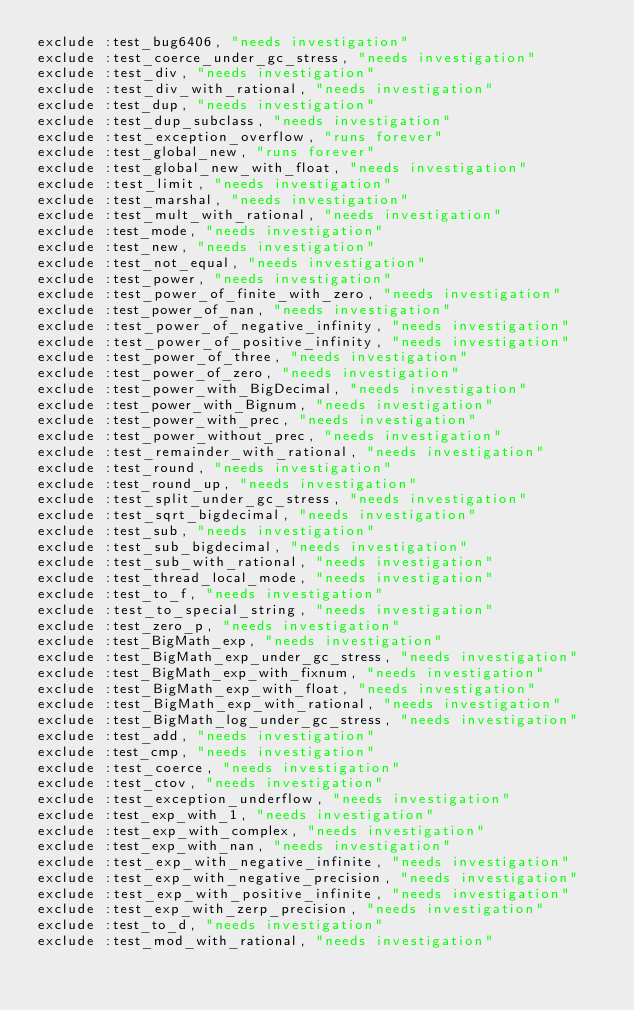Convert code to text. <code><loc_0><loc_0><loc_500><loc_500><_Ruby_>exclude :test_bug6406, "needs investigation"
exclude :test_coerce_under_gc_stress, "needs investigation"
exclude :test_div, "needs investigation"
exclude :test_div_with_rational, "needs investigation"
exclude :test_dup, "needs investigation"
exclude :test_dup_subclass, "needs investigation"
exclude :test_exception_overflow, "runs forever"
exclude :test_global_new, "runs forever"
exclude :test_global_new_with_float, "needs investigation"
exclude :test_limit, "needs investigation"
exclude :test_marshal, "needs investigation"
exclude :test_mult_with_rational, "needs investigation"
exclude :test_mode, "needs investigation"
exclude :test_new, "needs investigation"
exclude :test_not_equal, "needs investigation"
exclude :test_power, "needs investigation"
exclude :test_power_of_finite_with_zero, "needs investigation"
exclude :test_power_of_nan, "needs investigation"
exclude :test_power_of_negative_infinity, "needs investigation"
exclude :test_power_of_positive_infinity, "needs investigation"
exclude :test_power_of_three, "needs investigation"
exclude :test_power_of_zero, "needs investigation"
exclude :test_power_with_BigDecimal, "needs investigation"
exclude :test_power_with_Bignum, "needs investigation"
exclude :test_power_with_prec, "needs investigation"
exclude :test_power_without_prec, "needs investigation"
exclude :test_remainder_with_rational, "needs investigation"
exclude :test_round, "needs investigation"
exclude :test_round_up, "needs investigation"
exclude :test_split_under_gc_stress, "needs investigation"
exclude :test_sqrt_bigdecimal, "needs investigation"
exclude :test_sub, "needs investigation"
exclude :test_sub_bigdecimal, "needs investigation"
exclude :test_sub_with_rational, "needs investigation"
exclude :test_thread_local_mode, "needs investigation"
exclude :test_to_f, "needs investigation"
exclude :test_to_special_string, "needs investigation"
exclude :test_zero_p, "needs investigation"
exclude :test_BigMath_exp, "needs investigation"
exclude :test_BigMath_exp_under_gc_stress, "needs investigation"
exclude :test_BigMath_exp_with_fixnum, "needs investigation"
exclude :test_BigMath_exp_with_float, "needs investigation"
exclude :test_BigMath_exp_with_rational, "needs investigation"
exclude :test_BigMath_log_under_gc_stress, "needs investigation"
exclude :test_add, "needs investigation"
exclude :test_cmp, "needs investigation"
exclude :test_coerce, "needs investigation"
exclude :test_ctov, "needs investigation"
exclude :test_exception_underflow, "needs investigation"
exclude :test_exp_with_1, "needs investigation"
exclude :test_exp_with_complex, "needs investigation"
exclude :test_exp_with_nan, "needs investigation"
exclude :test_exp_with_negative_infinite, "needs investigation"
exclude :test_exp_with_negative_precision, "needs investigation"
exclude :test_exp_with_positive_infinite, "needs investigation"
exclude :test_exp_with_zerp_precision, "needs investigation"
exclude :test_to_d, "needs investigation"
exclude :test_mod_with_rational, "needs investigation"
</code> 